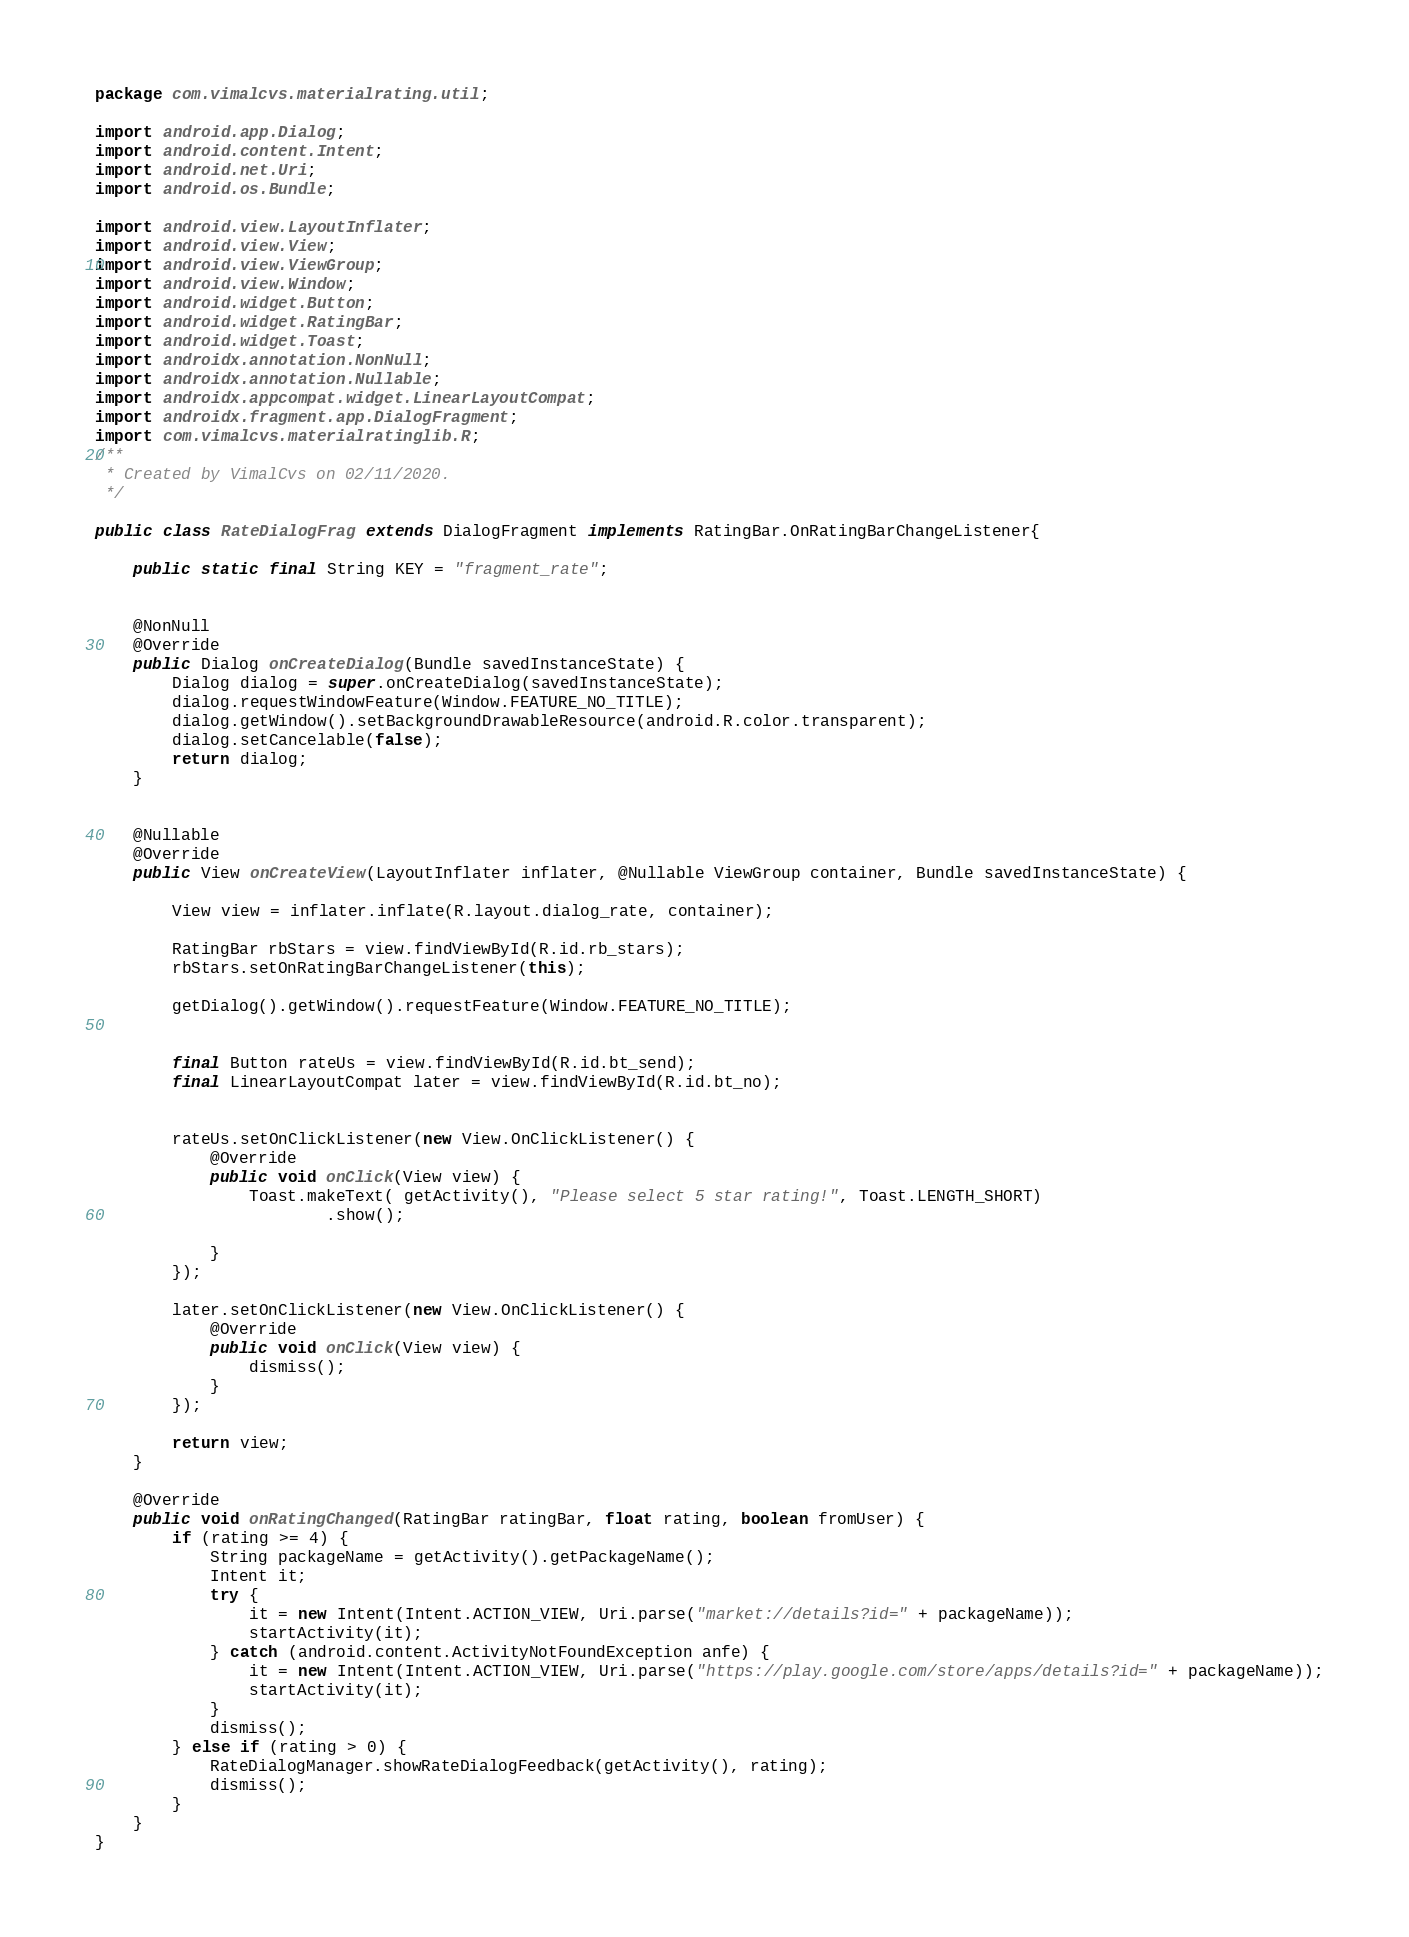Convert code to text. <code><loc_0><loc_0><loc_500><loc_500><_Java_>package com.vimalcvs.materialrating.util;

import android.app.Dialog;
import android.content.Intent;
import android.net.Uri;
import android.os.Bundle;

import android.view.LayoutInflater;
import android.view.View;
import android.view.ViewGroup;
import android.view.Window;
import android.widget.Button;
import android.widget.RatingBar;
import android.widget.Toast;
import androidx.annotation.NonNull;
import androidx.annotation.Nullable;
import androidx.appcompat.widget.LinearLayoutCompat;
import androidx.fragment.app.DialogFragment;
import com.vimalcvs.materialratinglib.R;
/**
 * Created by VimalCvs on 02/11/2020.
 */

public class RateDialogFrag extends DialogFragment implements RatingBar.OnRatingBarChangeListener{

    public static final String KEY = "fragment_rate";


    @NonNull
    @Override
    public Dialog onCreateDialog(Bundle savedInstanceState) {
        Dialog dialog = super.onCreateDialog(savedInstanceState);
        dialog.requestWindowFeature(Window.FEATURE_NO_TITLE);
        dialog.getWindow().setBackgroundDrawableResource(android.R.color.transparent);
        dialog.setCancelable(false);
        return dialog;
    }


    @Nullable
    @Override
    public View onCreateView(LayoutInflater inflater, @Nullable ViewGroup container, Bundle savedInstanceState) {

        View view = inflater.inflate(R.layout.dialog_rate, container);

        RatingBar rbStars = view.findViewById(R.id.rb_stars);
        rbStars.setOnRatingBarChangeListener(this);

        getDialog().getWindow().requestFeature(Window.FEATURE_NO_TITLE);


        final Button rateUs = view.findViewById(R.id.bt_send);
        final LinearLayoutCompat later = view.findViewById(R.id.bt_no);


        rateUs.setOnClickListener(new View.OnClickListener() {
            @Override
            public void onClick(View view) {
                Toast.makeText( getActivity(), "Please select 5 star rating!", Toast.LENGTH_SHORT)
                        .show();

            }
        });

        later.setOnClickListener(new View.OnClickListener() {
            @Override
            public void onClick(View view) {
                dismiss();
            }
        });

        return view;
    }

    @Override
    public void onRatingChanged(RatingBar ratingBar, float rating, boolean fromUser) {
        if (rating >= 4) {
            String packageName = getActivity().getPackageName();
            Intent it;
            try {
                it = new Intent(Intent.ACTION_VIEW, Uri.parse("market://details?id=" + packageName));
                startActivity(it);
            } catch (android.content.ActivityNotFoundException anfe) {
                it = new Intent(Intent.ACTION_VIEW, Uri.parse("https://play.google.com/store/apps/details?id=" + packageName));
                startActivity(it);
            }
            dismiss();
        } else if (rating > 0) {
            RateDialogManager.showRateDialogFeedback(getActivity(), rating);
            dismiss();
        }
    }
}</code> 